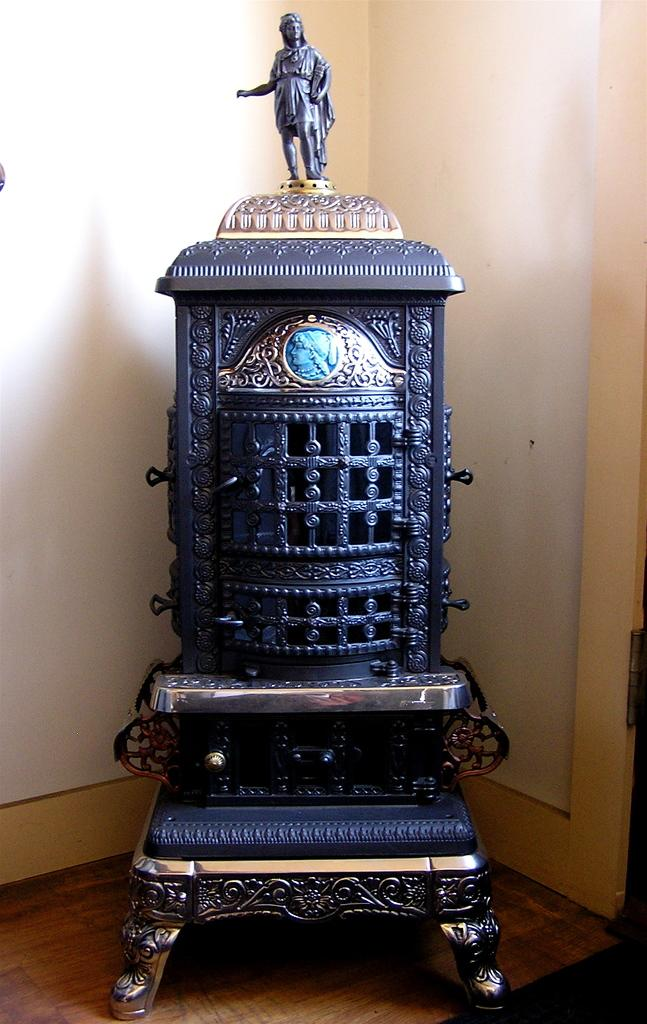What type of object can be seen in the middle of the image? There is an object in the image that resembles an antique. Can you describe the location of the object in the image? The object is in the middle of the image. What can be seen in the background of the image? There is a wall in the background of the image. What type of weather can be seen in the image? There is no weather visible in the image, as it is focused on an object and a wall in the background. 